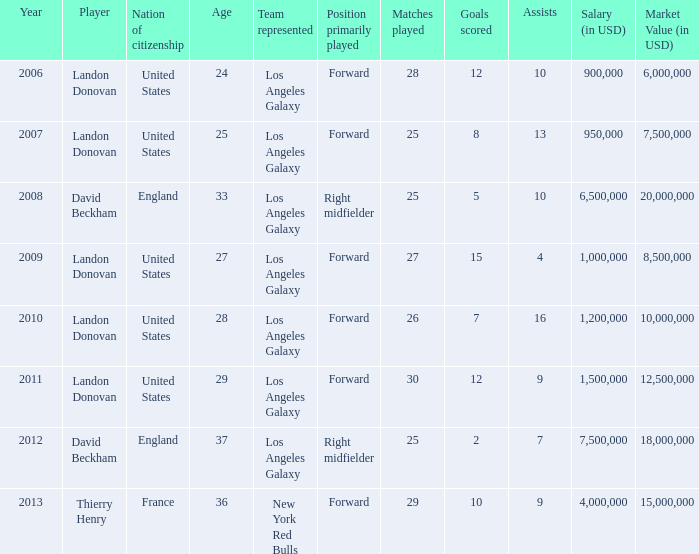What is the sum of all the years that Landon Donovan won the ESPY award? 5.0. 